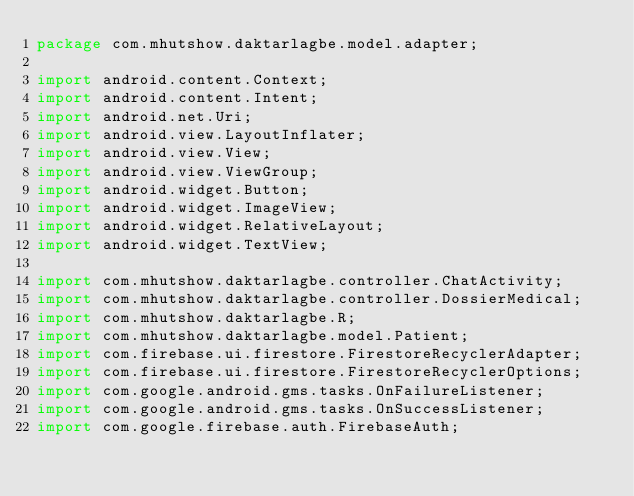Convert code to text. <code><loc_0><loc_0><loc_500><loc_500><_Java_>package com.mhutshow.daktarlagbe.model.adapter;

import android.content.Context;
import android.content.Intent;
import android.net.Uri;
import android.view.LayoutInflater;
import android.view.View;
import android.view.ViewGroup;
import android.widget.Button;
import android.widget.ImageView;
import android.widget.RelativeLayout;
import android.widget.TextView;

import com.mhutshow.daktarlagbe.controller.ChatActivity;
import com.mhutshow.daktarlagbe.controller.DossierMedical;
import com.mhutshow.daktarlagbe.R;
import com.mhutshow.daktarlagbe.model.Patient;
import com.firebase.ui.firestore.FirestoreRecyclerAdapter;
import com.firebase.ui.firestore.FirestoreRecyclerOptions;
import com.google.android.gms.tasks.OnFailureListener;
import com.google.android.gms.tasks.OnSuccessListener;
import com.google.firebase.auth.FirebaseAuth;</code> 